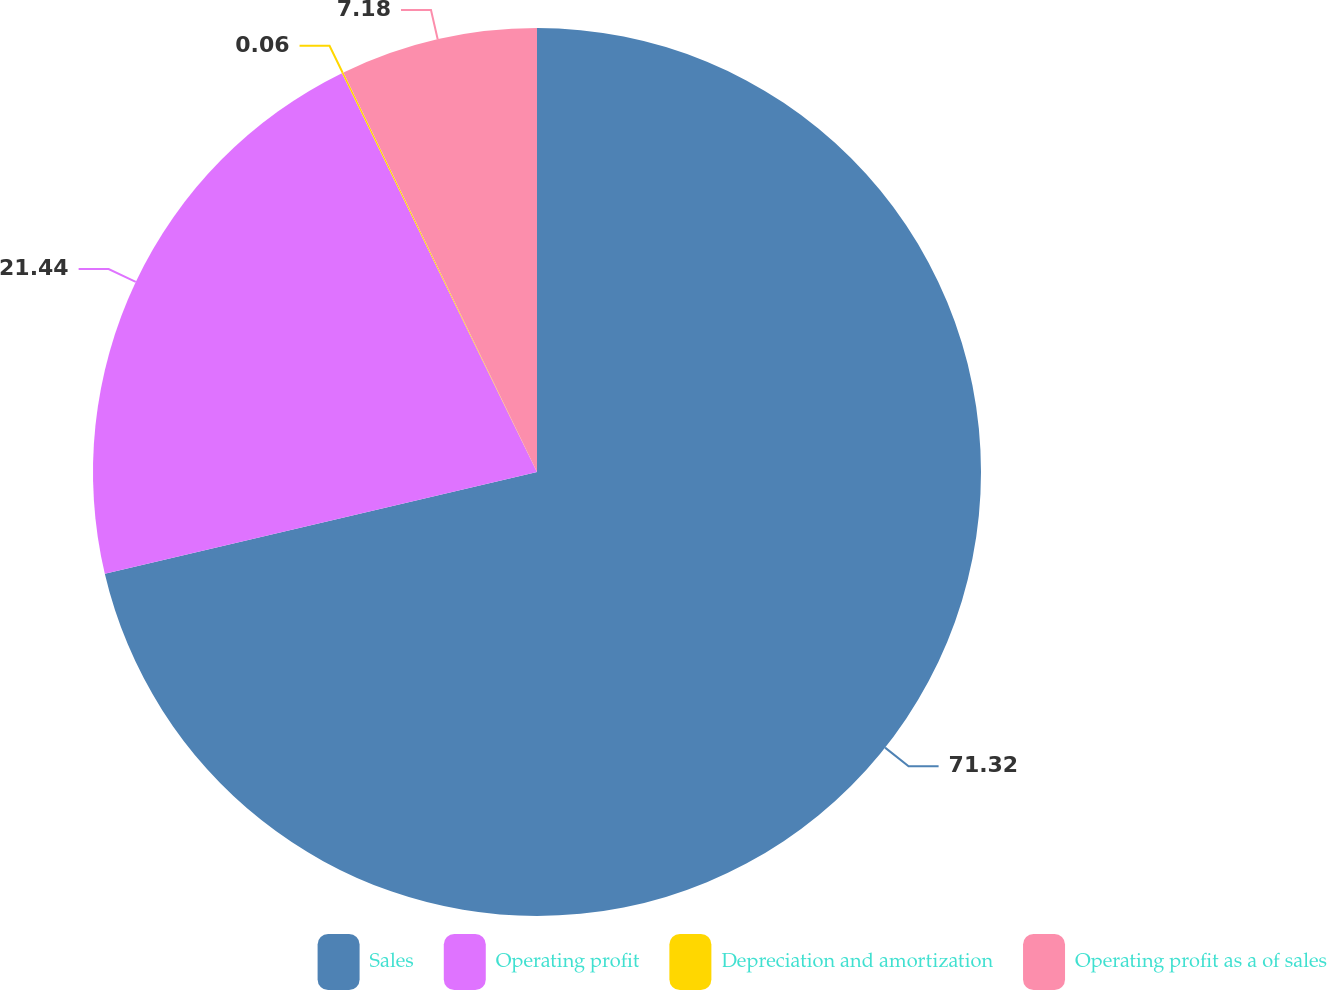<chart> <loc_0><loc_0><loc_500><loc_500><pie_chart><fcel>Sales<fcel>Operating profit<fcel>Depreciation and amortization<fcel>Operating profit as a of sales<nl><fcel>71.32%<fcel>21.44%<fcel>0.06%<fcel>7.18%<nl></chart> 